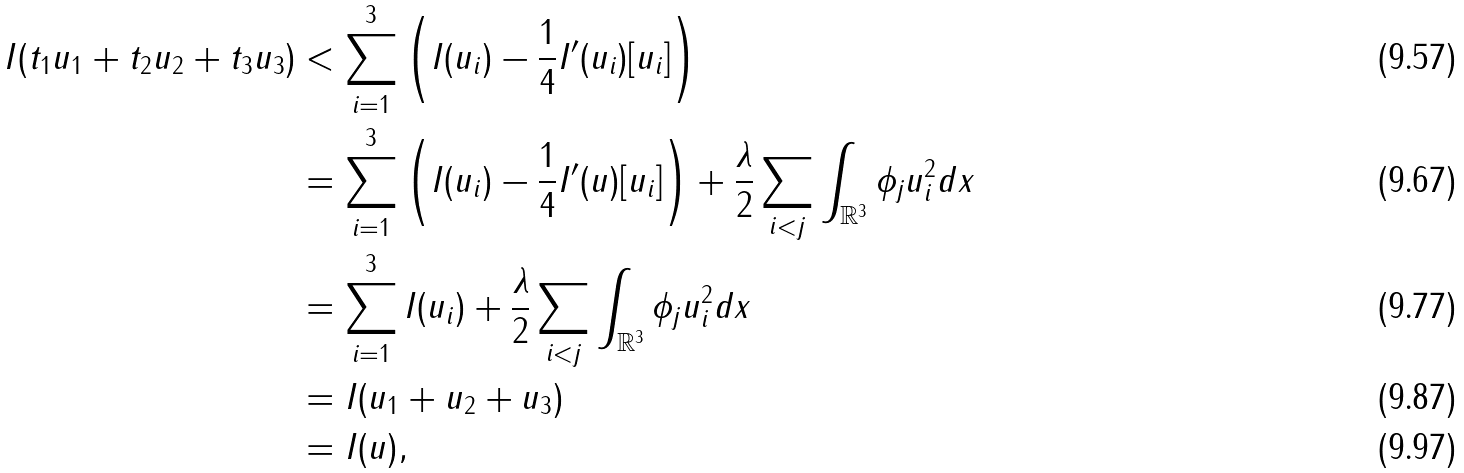<formula> <loc_0><loc_0><loc_500><loc_500>I ( t _ { 1 } u _ { 1 } + t _ { 2 } u _ { 2 } + t _ { 3 } u _ { 3 } ) & < \sum _ { i = 1 } ^ { 3 } \left ( I ( u _ { i } ) - \frac { 1 } { 4 } I ^ { \prime } ( u _ { i } ) [ u _ { i } ] \right ) \\ & = \sum _ { i = 1 } ^ { 3 } \left ( I ( u _ { i } ) - \frac { 1 } { 4 } I ^ { \prime } ( u ) [ u _ { i } ] \right ) + \frac { \lambda } { 2 } \sum _ { i < j } \int _ { \mathbb { R } ^ { 3 } } \phi _ { j } u _ { i } ^ { 2 } d x \\ & = \sum _ { i = 1 } ^ { 3 } I ( u _ { i } ) + \frac { \lambda } { 2 } \sum _ { i < j } \int _ { \mathbb { R } ^ { 3 } } \phi _ { j } u _ { i } ^ { 2 } d x \\ & = I ( u _ { 1 } + u _ { 2 } + u _ { 3 } ) \\ & = I ( u ) ,</formula> 